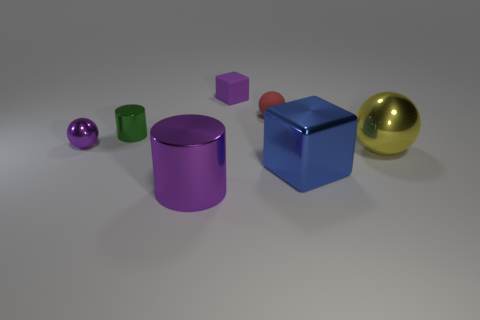What materials are the objects in the image made of? The objects in the image appear to be made of various materials that render different finishes. For instance, the gold sphere has a reflective shiny surface suggesting a metallic material, while the blue cube has a matte finish perhaps indicating a plastic or painted surface. 